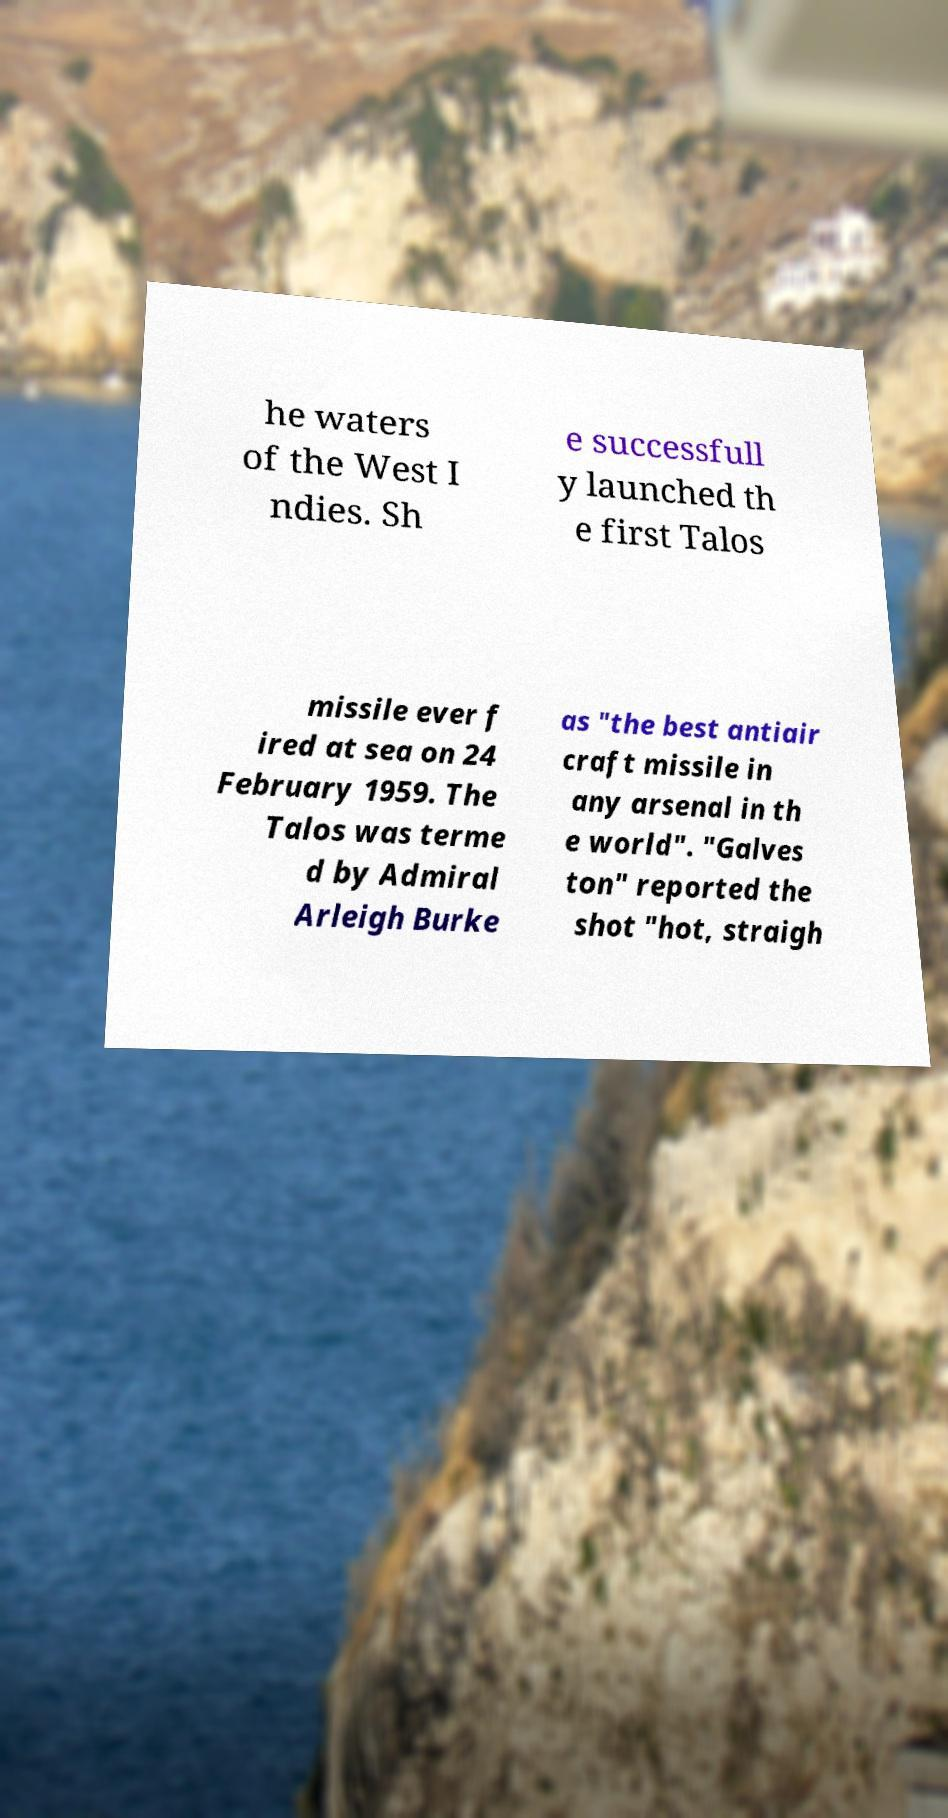For documentation purposes, I need the text within this image transcribed. Could you provide that? he waters of the West I ndies. Sh e successfull y launched th e first Talos missile ever f ired at sea on 24 February 1959. The Talos was terme d by Admiral Arleigh Burke as "the best antiair craft missile in any arsenal in th e world". "Galves ton" reported the shot "hot, straigh 